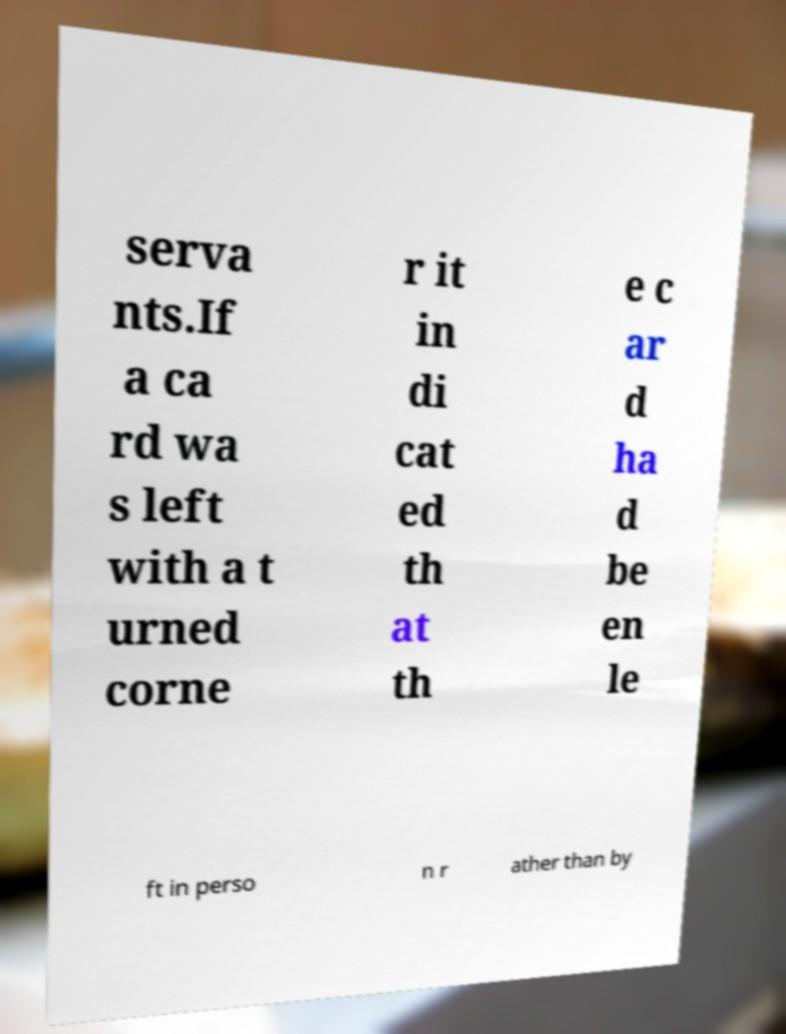Can you accurately transcribe the text from the provided image for me? serva nts.If a ca rd wa s left with a t urned corne r it in di cat ed th at th e c ar d ha d be en le ft in perso n r ather than by 